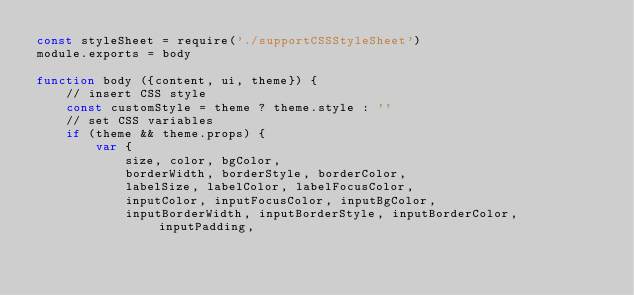Convert code to text. <code><loc_0><loc_0><loc_500><loc_500><_JavaScript_>const styleSheet = require('./supportCSSStyleSheet')
module.exports = body

function body ({content, ui, theme}) {
    // insert CSS style
    const customStyle = theme ? theme.style : ''
    // set CSS variables
    if (theme && theme.props) {
        var {
            size, color, bgColor, 
            borderWidth, borderStyle, borderColor, 
            labelSize, labelColor, labelFocusColor, 
            inputColor, inputFocusColor, inputBgColor, 
            inputBorderWidth, inputBorderStyle, inputBorderColor, inputPadding, </code> 